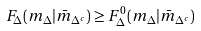Convert formula to latex. <formula><loc_0><loc_0><loc_500><loc_500>F _ { \Delta } ( m _ { \Delta } | \bar { m } _ { \Delta ^ { c } } ) \geq F ^ { 0 } _ { \Delta } ( m _ { \Delta } | \bar { m } _ { \Delta ^ { c } } )</formula> 